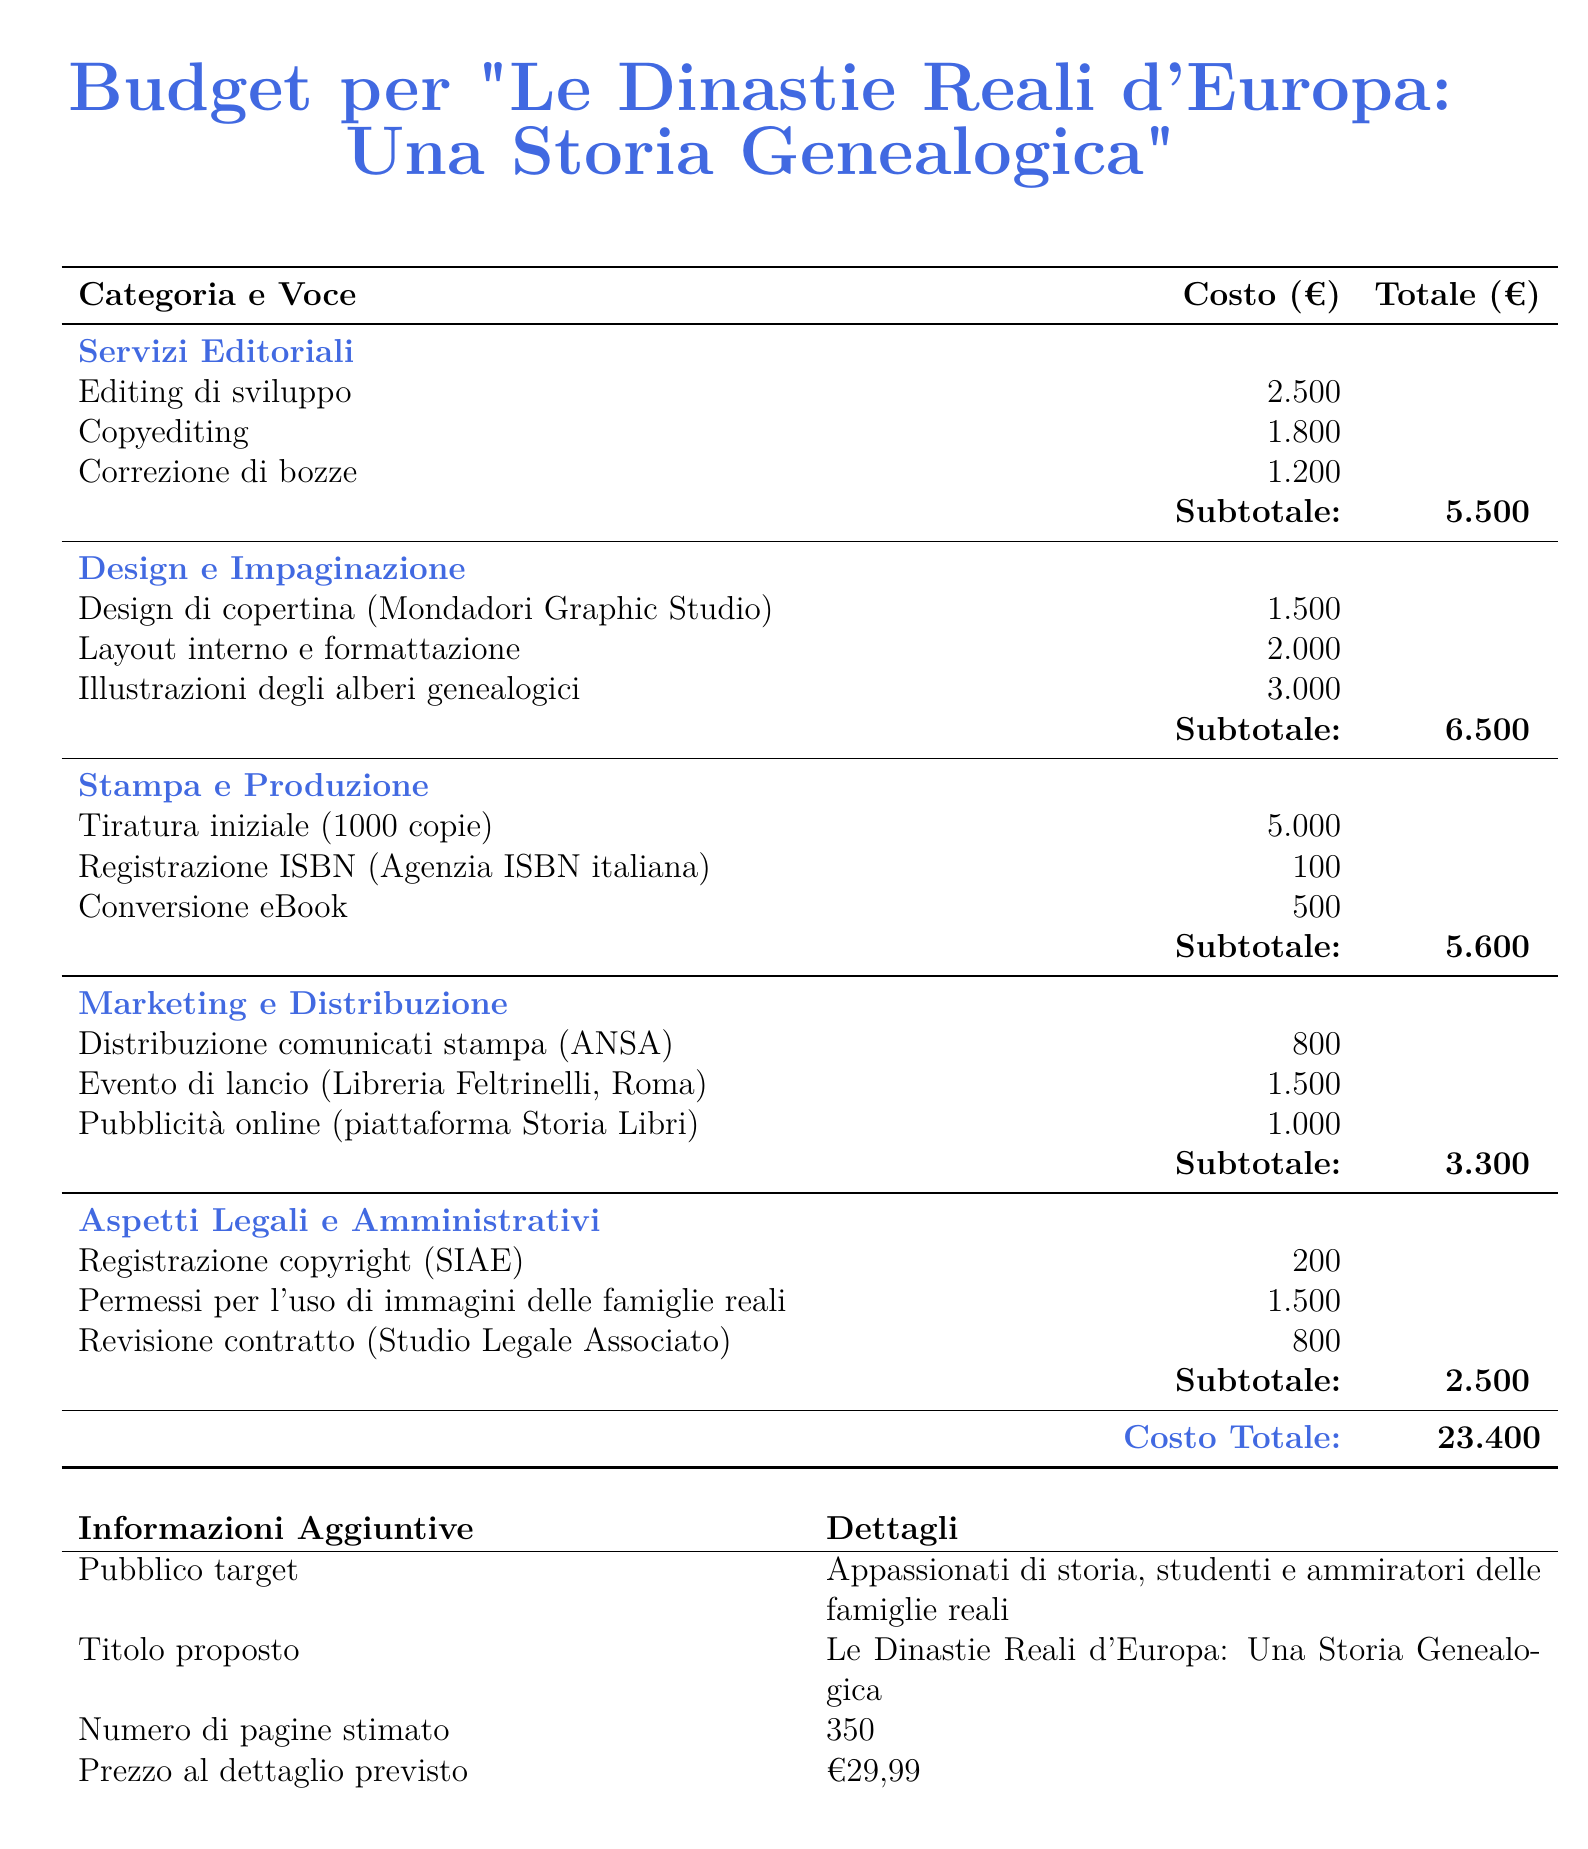What is the total cost of publishing the book? The total cost is provided at the end of the budget, which sums up all the individual costs.
Answer: 23.400 What is the cost of editing di sviluppo? This is a specific service listed under "Servizi Editoriali," with its cost clearly stated.
Answer: 2.500 How many copies are included in the initial print run? The number of copies for the initial tiratura is directly mentioned in the production section.
Answer: 1000 What is the expected retail price of the book? The retail price is mentioned in the additional information section.
Answer: €29,99 What is the total cost for design and impaginazione services? The subtotal for design and formatting services is listed to summarize the individual costs.
Answer: 6.500 What kind of event is planned for marketing? The type of marketing event is clearly specified under "Marketing e Distribuzione."
Answer: Evento di lancio How much will it cost to register the copyright? This specific legal cost is listed under "Aspetti Legali e Amministrativi."
Answer: 200 Which studio is responsible for the design of the book cover? The studio responsible for the cover design is mentioned specifically in the budget.
Answer: Mondadori Graphic Studio What is the estimated number of pages for the book? The document specifies the estimated total number of pages in the additional information section.
Answer: 350 